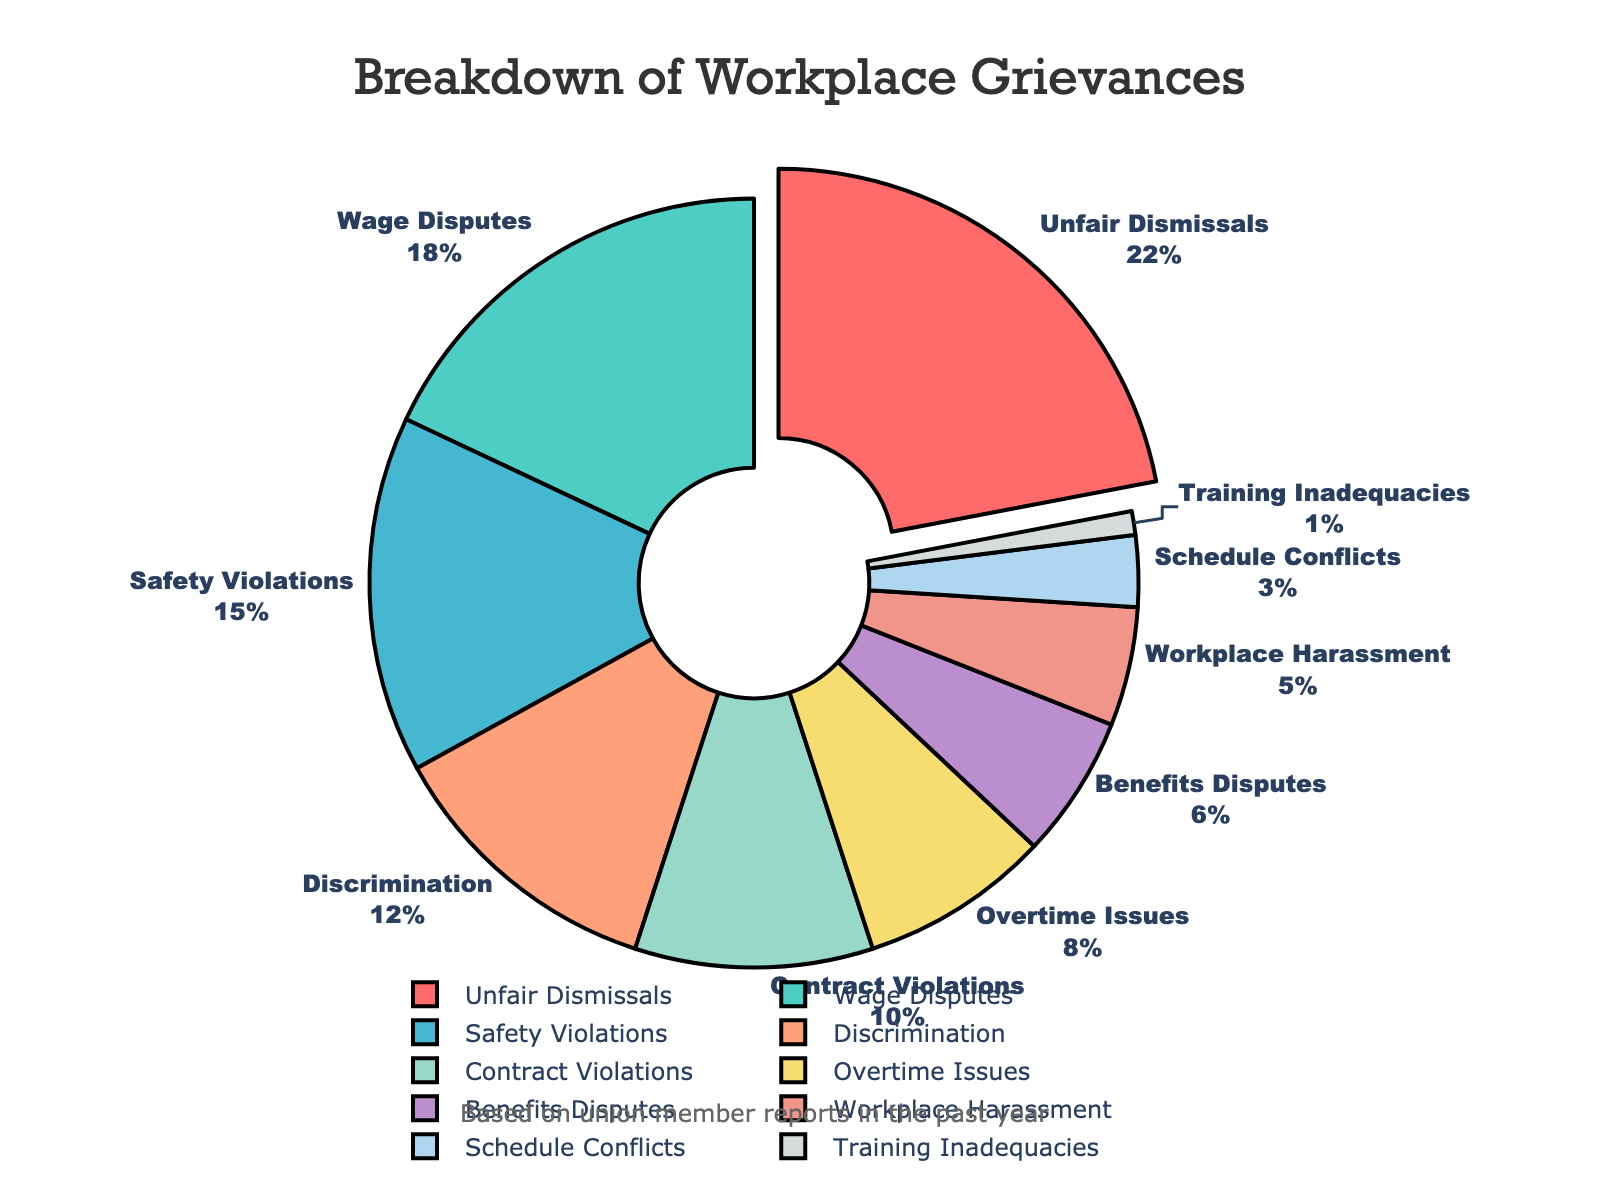What percentage of grievances filed were for Wage Disputes? Locate the slice labeled 'Wage Disputes' on the pie chart and read the corresponding percentage displayed.
Answer: 18% Which category had the highest percentage of grievances filed? Identify the slice that is visually pulled out from the pie chart, indicating it has the highest percentage. This is labeled 'Unfair Dismissals'.
Answer: Unfair Dismissals How does the percentage of Safety Violations compare to Discrimination grievances? Identify the slices for 'Safety Violations' and 'Discrimination'. Note the percentages provided for each (15% and 12%, respectively). Compare these values to determine which is higher.
Answer: Safety Violations are higher by 3% What is the total percentage of grievances related to Unfair Dismissals and Benefits Disputes? Sum the percentages given for 'Unfair Dismissals' and 'Benefits Disputes' (22% and 6%, respectively). The calculation is 22 + 6.
Answer: 28% What is the percentage difference between Overtime Issues and Schedule Conflicts? Identify the percentages for 'Overtime Issues' and 'Schedule Conflicts' (8% and 3%, respectively). Subtract the smaller percentage from the larger one (8 - 3).
Answer: 5% Which category accounts for the smallest percentage of grievances? Locate the smallest slice on the pie chart. The label for this slice is 'Training Inadequacies'.
Answer: Training Inadequacies Is the percentage of Wage Disputes higher than that of Safety Violations? Compare the percentages for 'Wage Disputes' (18%) and 'Safety Violations' (15%).
Answer: Yes Which three categories combined make up approximately half of the grievances filed? Identify the three largest slices on the pie chart: 'Unfair Dismissals' (22%), 'Wage Disputes' (18%), and 'Safety Violations' (15%). Summing these (22 + 18 + 15) gives 55%, which is approximately half.
Answer: Unfair Dismissals, Wage Disputes, Safety Violations What percentage of grievances were filed for issues other than the top three categories? Sum the percentages for the top three categories ('Unfair Dismissals', 'Wage Disputes', and 'Safety Violations') which is 22 + 18 + 15 = 55%. Subtract this sum from 100% to find the remaining percentage.
Answer: 45% How many categories have a percentage of grievances less than 10%? Identify slices with percentages below 10%: 'Contract Violations', 'Overtime Issues', 'Benefits Disputes', 'Workplace Harassment', 'Schedule Conflicts', 'Training Inadequacies'. Count these slices.
Answer: 6 